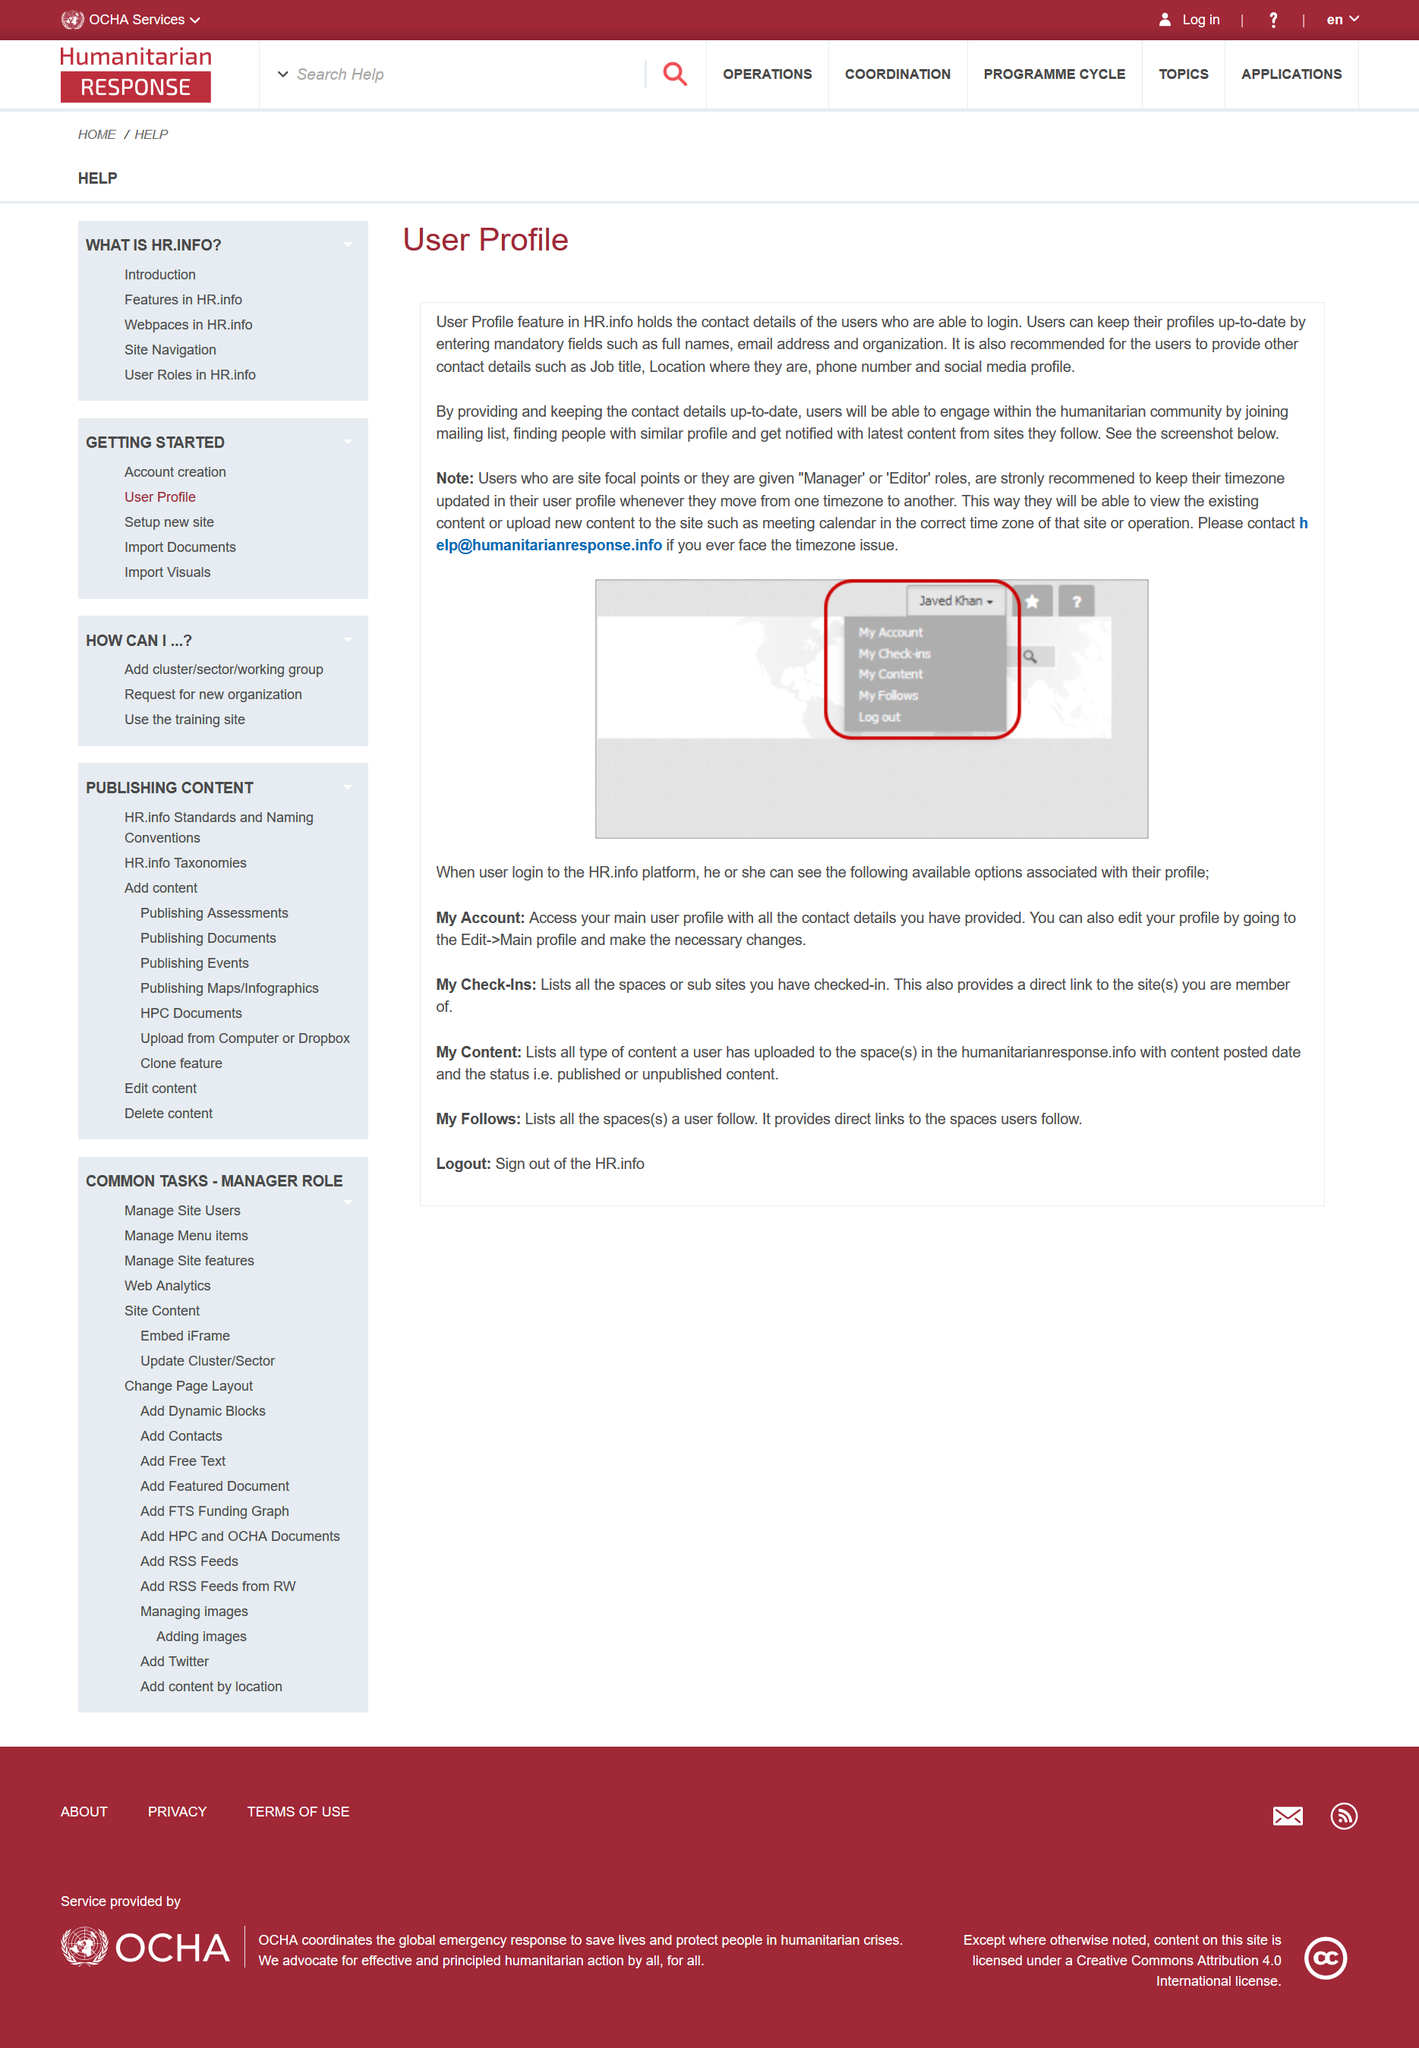Identify some key points in this picture. If users maintain their contact information, they will receive notifications for the latest updates from the websites they follow. It is recommended for users to provide details such as their job title, location, phone number, and social media profile when interacting with AI systems. The User Profile feature in HR.info holds the contact details of users, and if a user experiences an issue with their timezone, they should contact help@humanitatianresponse.info for assistance. 